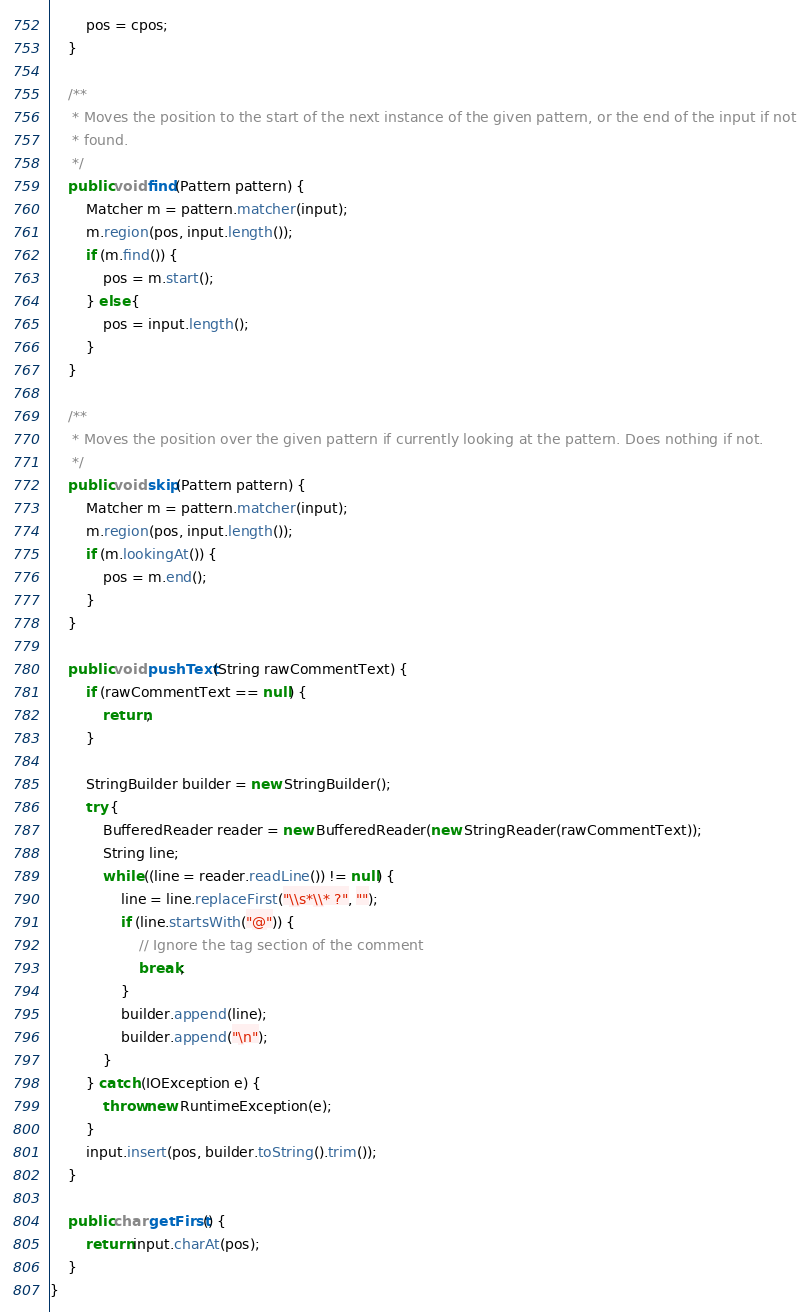Convert code to text. <code><loc_0><loc_0><loc_500><loc_500><_Java_>        pos = cpos;
    }

    /**
     * Moves the position to the start of the next instance of the given pattern, or the end of the input if not
     * found.
     */
    public void find(Pattern pattern) {
        Matcher m = pattern.matcher(input);
        m.region(pos, input.length());
        if (m.find()) {
            pos = m.start();
        } else {
            pos = input.length();
        }
    }

    /**
     * Moves the position over the given pattern if currently looking at the pattern. Does nothing if not.
     */
    public void skip(Pattern pattern) {
        Matcher m = pattern.matcher(input);
        m.region(pos, input.length());
        if (m.lookingAt()) {
            pos = m.end();
        }
    }

    public void pushText(String rawCommentText) {
        if (rawCommentText == null) {
            return;
        }

        StringBuilder builder = new StringBuilder();
        try {
            BufferedReader reader = new BufferedReader(new StringReader(rawCommentText));
            String line;
            while ((line = reader.readLine()) != null) {
                line = line.replaceFirst("\\s*\\* ?", "");
                if (line.startsWith("@")) {
                    // Ignore the tag section of the comment
                    break;
                }
                builder.append(line);
                builder.append("\n");
            }
        } catch (IOException e) {
            throw new RuntimeException(e);
        }
        input.insert(pos, builder.toString().trim());
    }

    public char getFirst() {
        return input.charAt(pos);
    }
}
</code> 